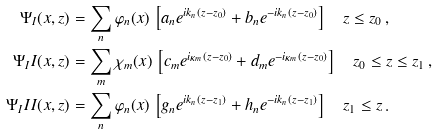<formula> <loc_0><loc_0><loc_500><loc_500>\Psi _ { I } ( x , z ) & = \sum _ { n } \varphi _ { n } ( x ) \, \left [ a _ { n } e ^ { i k _ { n } ( z - z _ { 0 } ) } + b _ { n } e ^ { - i k _ { n } ( z - z _ { 0 } ) } \right ] \quad z \leq z _ { 0 } \, , \\ \Psi _ { I } I ( x , z ) & = \sum _ { m } \chi _ { m } ( x ) \, \left [ c _ { m } e ^ { i \kappa _ { m } ( z - z _ { 0 } ) } + d _ { m } e ^ { - i \kappa _ { m } ( z - z _ { 0 } ) } \right ] \quad z _ { 0 } \leq z \leq z _ { 1 } \, , \\ \Psi _ { I } I I ( x , z ) & = \sum _ { n } \varphi _ { n } ( x ) \, \left [ g _ { n } e ^ { i k _ { n } ( z - z _ { 1 } ) } + h _ { n } e ^ { - i k _ { n } ( z - z _ { 1 } ) } \right ] \quad z _ { 1 } \leq z \, .</formula> 